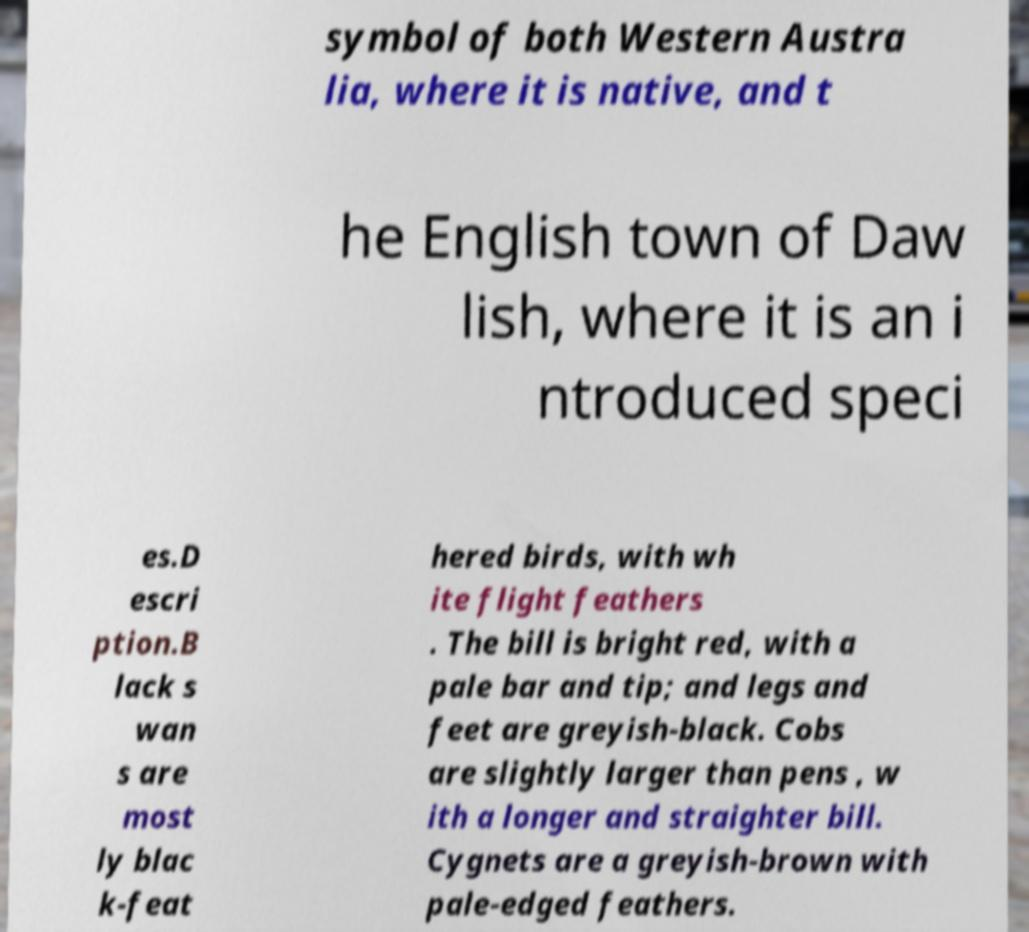I need the written content from this picture converted into text. Can you do that? symbol of both Western Austra lia, where it is native, and t he English town of Daw lish, where it is an i ntroduced speci es.D escri ption.B lack s wan s are most ly blac k-feat hered birds, with wh ite flight feathers . The bill is bright red, with a pale bar and tip; and legs and feet are greyish-black. Cobs are slightly larger than pens , w ith a longer and straighter bill. Cygnets are a greyish-brown with pale-edged feathers. 